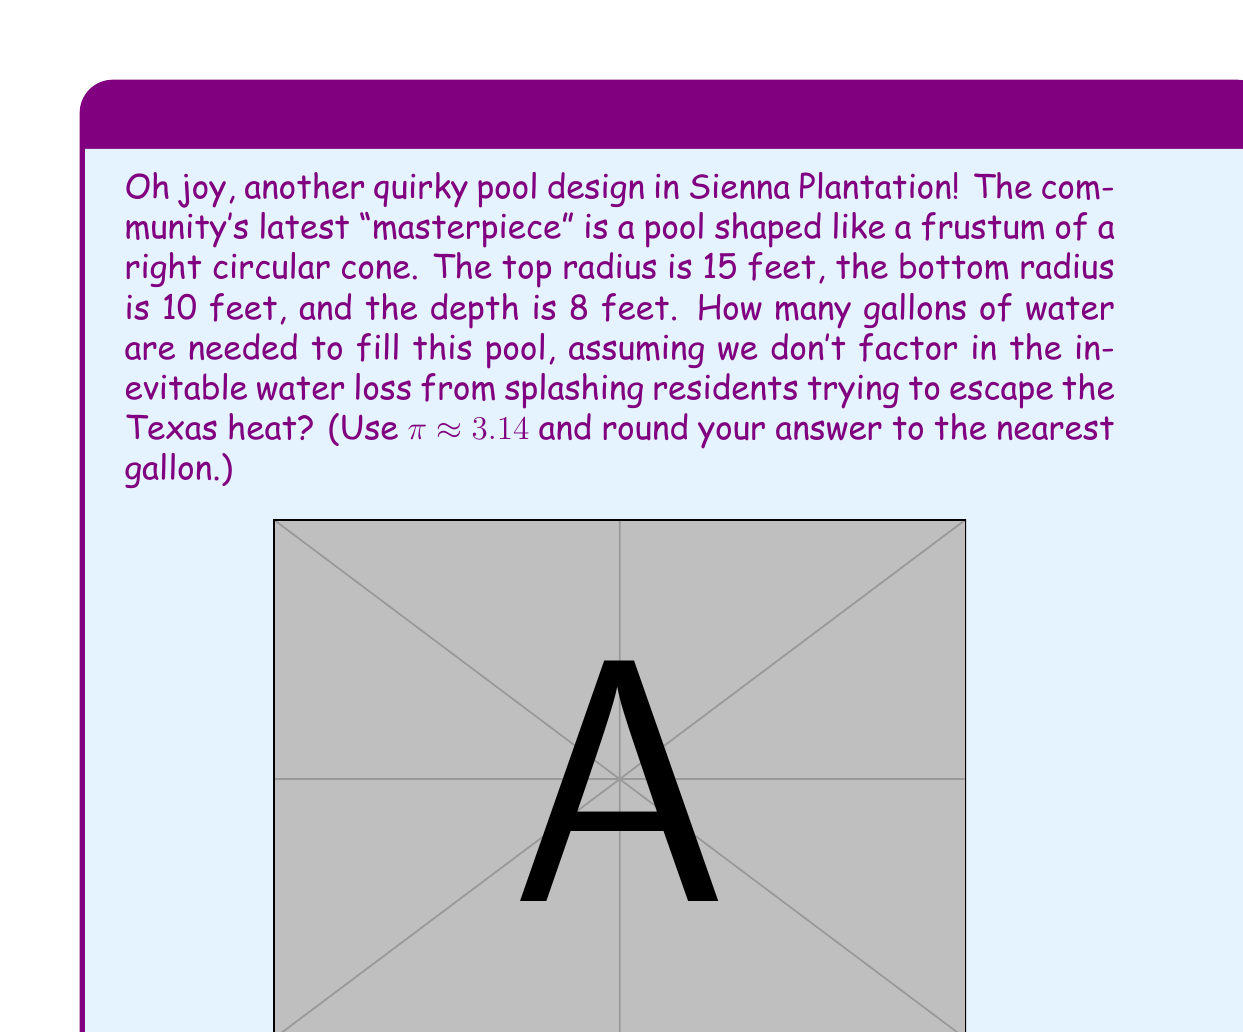What is the answer to this math problem? Let's approach this step-by-step:

1) The volume of a frustum of a right circular cone is given by the formula:

   $$V = \frac{1}{3}\pi h(R^2 + r^2 + Rr)$$

   where $h$ is the height, $R$ is the radius of the larger base, and $r$ is the radius of the smaller base.

2) We have:
   $h = 8$ feet
   $R = 15$ feet
   $r = 10$ feet

3) Let's substitute these values into our formula:

   $$V = \frac{1}{3}\pi \cdot 8(15^2 + 10^2 + 15 \cdot 10)$$

4) Simplify:
   $$V = \frac{8\pi}{3}(225 + 100 + 150)$$
   $$V = \frac{8\pi}{3}(475)$$

5) Calculate:
   $$V = 1266.67\pi$$
   $$V \approx 1266.67 \cdot 3.14 = 3977.33 \text{ cubic feet}$$

6) To convert cubic feet to gallons, we multiply by 7.48 gallons per cubic foot:

   $$3977.33 \cdot 7.48 \approx 29,750.43 \text{ gallons}$$

7) Rounding to the nearest gallon:

   $$29,750 \text{ gallons}$$
Answer: 29,750 gallons 